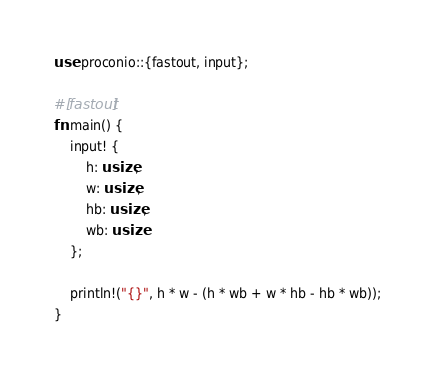<code> <loc_0><loc_0><loc_500><loc_500><_Rust_>use proconio::{fastout, input};

#[fastout]
fn main() {
    input! {
        h: usize,
        w: usize,
        hb: usize,
        wb: usize
    };

    println!("{}", h * w - (h * wb + w * hb - hb * wb));
}
</code> 